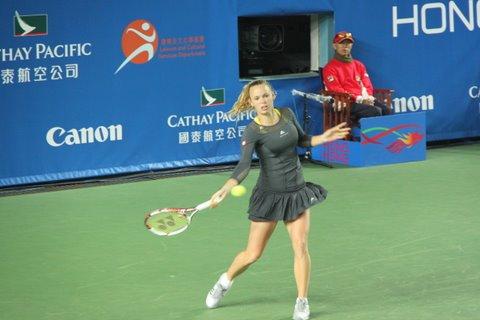Is this man holding a tennis racket?
Quick response, please. No. What are the words in red?
Short answer required. Hong kong. Who is sponsoring the timekeeping system for the tournament?
Give a very brief answer. Canon. What color is the player wearing?
Keep it brief. Black. What is the role of the man sitting down?
Keep it brief. Referee. Is this tennis player using both hands to hit the ball?
Short answer required. No. What letter is to the right of her head?
Write a very short answer. H. What is one sponsor of this event?
Quick response, please. Canon. 